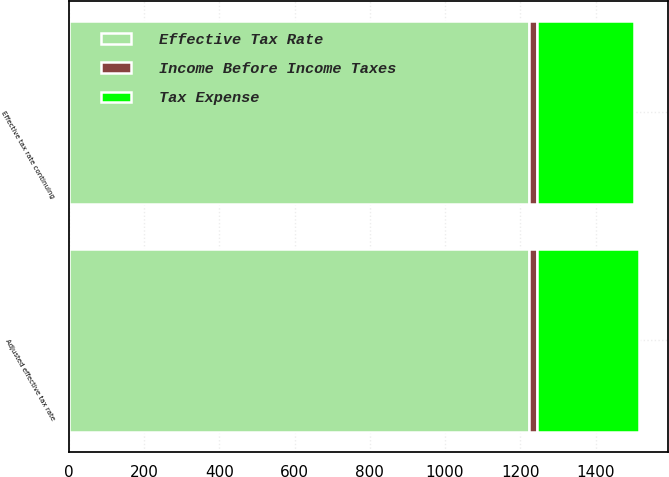Convert chart to OTSL. <chart><loc_0><loc_0><loc_500><loc_500><stacked_bar_chart><ecel><fcel>Effective tax rate continuing<fcel>Adjusted effective tax rate<nl><fcel>Effective Tax Rate<fcel>1222<fcel>1222<nl><fcel>Tax Expense<fcel>260<fcel>272<nl><fcel>Income Before Income Taxes<fcel>21.3<fcel>22.3<nl></chart> 